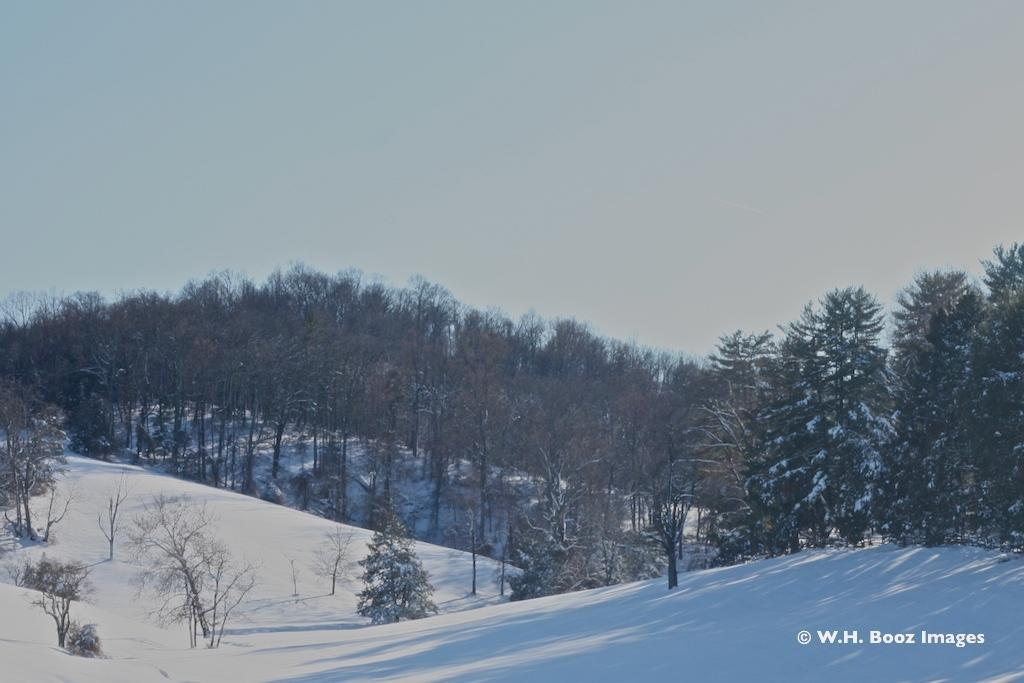What is located in the foreground of the image? There are mountains in the foreground of the image. What else can be seen in the image besides the mountains? There is text visible in the image, as well as trees. What is visible at the top of the image? The sky is visible at the top of the image. When was the image taken? The image was taken during the day. Where is the shelf located in the image? There is no shelf present in the image. How many times does the text need to be sorted in the image? There is no sorting of text in the image; it is simply visible. 